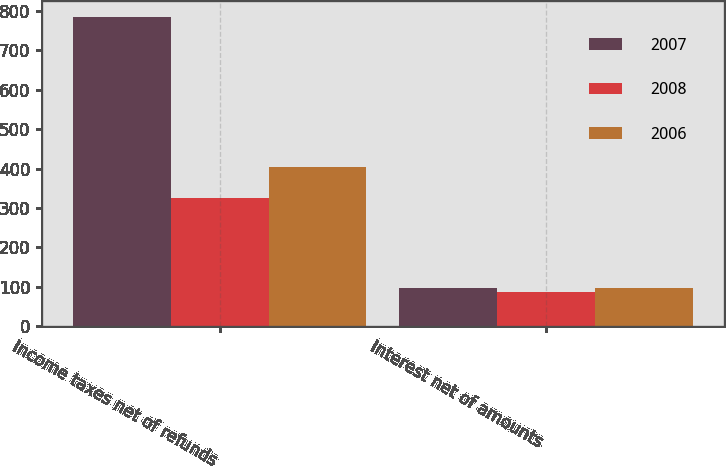Convert chart. <chart><loc_0><loc_0><loc_500><loc_500><stacked_bar_chart><ecel><fcel>Income taxes net of refunds<fcel>Interest net of amounts<nl><fcel>2007<fcel>785<fcel>97<nl><fcel>2008<fcel>324<fcel>88<nl><fcel>2006<fcel>403<fcel>96<nl></chart> 